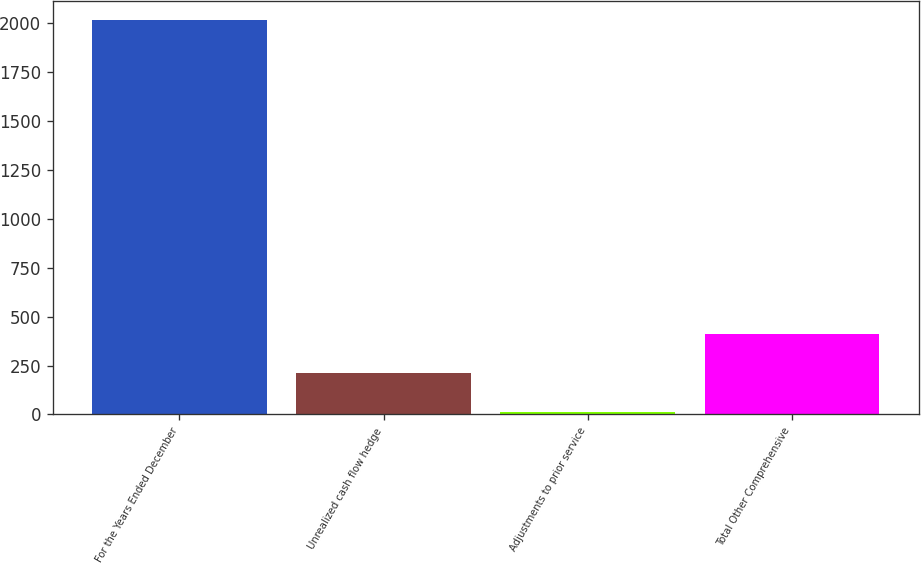<chart> <loc_0><loc_0><loc_500><loc_500><bar_chart><fcel>For the Years Ended December<fcel>Unrealized cash flow hedge<fcel>Adjustments to prior service<fcel>Total Other Comprehensive<nl><fcel>2013<fcel>211.92<fcel>11.8<fcel>412.04<nl></chart> 